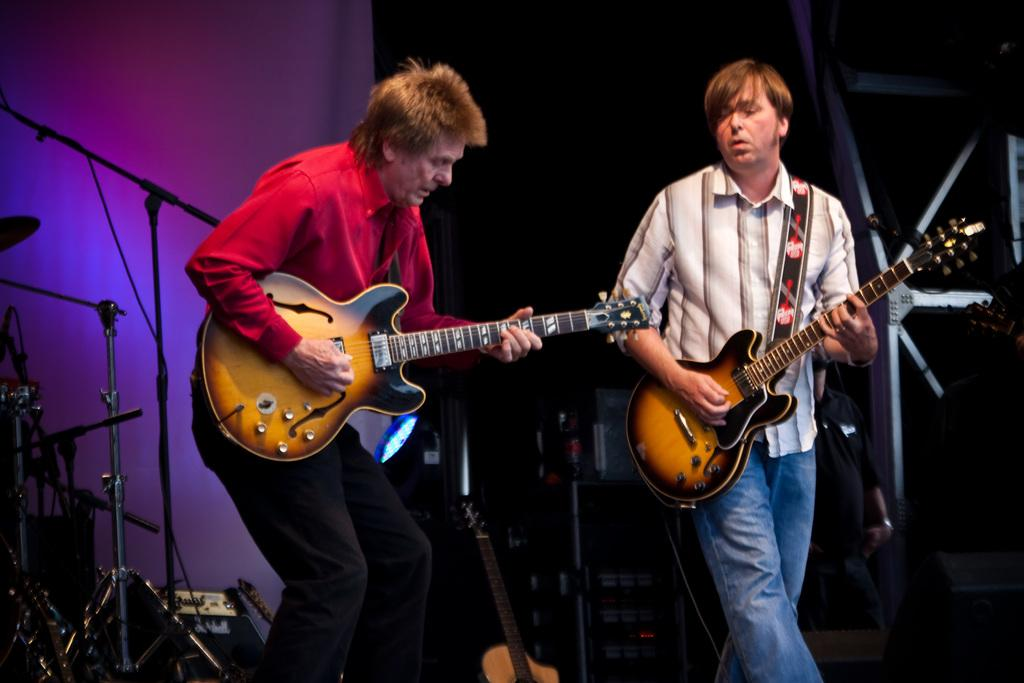How many people are in the image? There are two men in the image. What are the men doing in the image? The men are standing and playing guitar. What other objects related to music can be seen in the image? There are musical instruments and a microphone in the image. What type of meat is being prepared on the base in the image? There is no meat or base present in the image; it features two men playing guitar and related musical objects. 